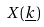Convert formula to latex. <formula><loc_0><loc_0><loc_500><loc_500>X ( \underline { k } )</formula> 